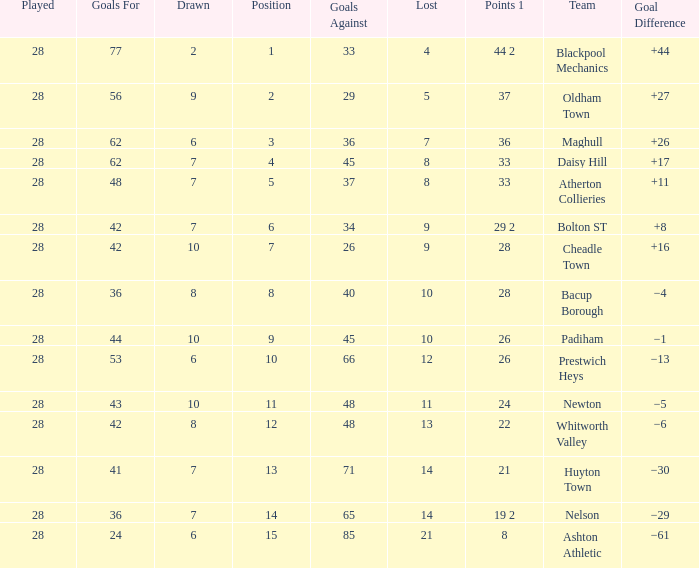What is the average played for entries with fewer than 65 goals against, points 1 of 19 2, and a position higher than 15? None. 